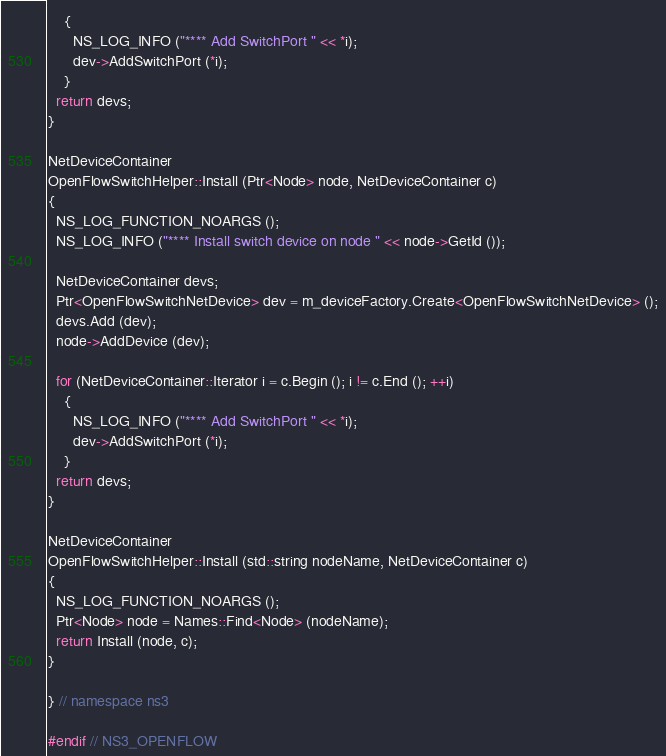<code> <loc_0><loc_0><loc_500><loc_500><_C++_>    {
      NS_LOG_INFO ("**** Add SwitchPort " << *i);
      dev->AddSwitchPort (*i);
    }
  return devs;
}

NetDeviceContainer
OpenFlowSwitchHelper::Install (Ptr<Node> node, NetDeviceContainer c)
{
  NS_LOG_FUNCTION_NOARGS ();
  NS_LOG_INFO ("**** Install switch device on node " << node->GetId ());

  NetDeviceContainer devs;
  Ptr<OpenFlowSwitchNetDevice> dev = m_deviceFactory.Create<OpenFlowSwitchNetDevice> ();
  devs.Add (dev);
  node->AddDevice (dev);

  for (NetDeviceContainer::Iterator i = c.Begin (); i != c.End (); ++i)
    {
      NS_LOG_INFO ("**** Add SwitchPort " << *i);
      dev->AddSwitchPort (*i);
    }
  return devs;
}

NetDeviceContainer
OpenFlowSwitchHelper::Install (std::string nodeName, NetDeviceContainer c)
{
  NS_LOG_FUNCTION_NOARGS ();
  Ptr<Node> node = Names::Find<Node> (nodeName);
  return Install (node, c);
}

} // namespace ns3

#endif // NS3_OPENFLOW
</code> 